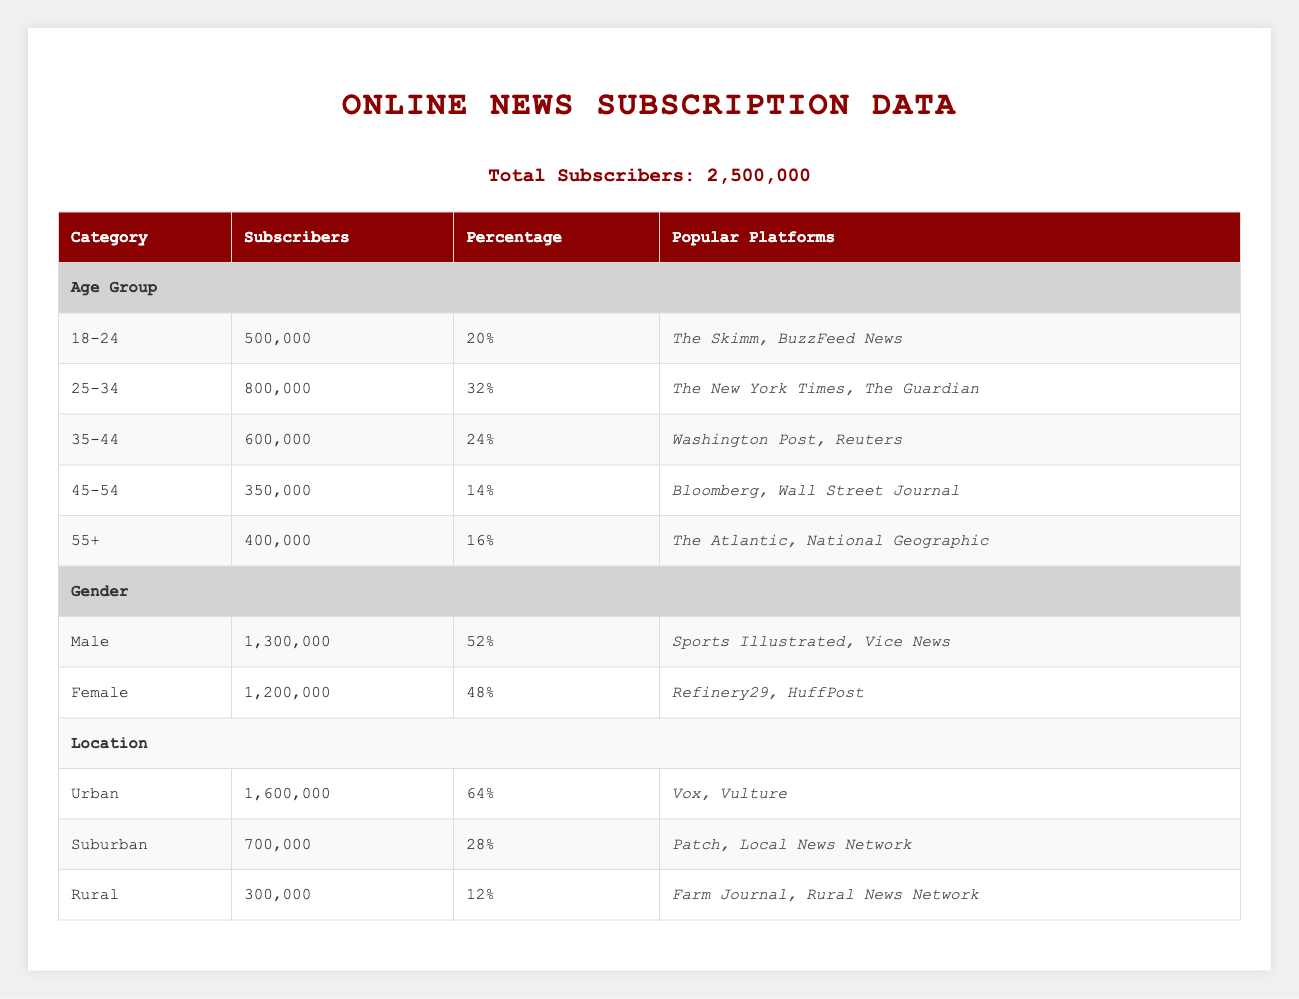What is the total number of subscribers for the online news platforms? The total number of subscribers is stated clearly at the top of the table as 2,500,000.
Answer: 2,500,000 Which age group has the highest number of subscribers? By reviewing the age group data, the group 25-34 has 800,000 subscribers, which is the highest compared to other age groups.
Answer: 25-34 What percentage of subscribers are from urban locations? The table lists the urban subscribers as 1,600,000 out of a total of 2,500,000. To find the percentage, we divide 1,600,000 by 2,500,000 and multiply by 100. This results in 64%.
Answer: 64% Is the number of male subscribers greater than the number of female subscribers? The table shows 1,300,000 male subscribers and 1,200,000 female subscribers. Since 1,300,000 is greater than 1,200,000, the statement is true.
Answer: Yes What is the combined number of subscribers for the 45-54 and 55+ age groups? Adding the subscribers from both age groups gives us 350,000 (for 45-54) + 400,000 (for 55+) = 750,000. This is the total for both age groups.
Answer: 750,000 Which demographic has the least subscribers in terms of location? Looking at the location demographic, rural has the smallest number of subscribers at 300,000 compared to urban (1,600,000) and suburban (700,000).
Answer: Rural What is the average number of subscribers across all age groups? To find the average, we sum the number of subscribers in each age group: 500,000 + 800,000 + 600,000 + 350,000 + 400,000 = 2,650,000. Dividing by the five age groups gives an average of 2,650,000 / 5 = 530,000.
Answer: 530,000 How many more subscribers are there among males than females? Males have 1,300,000 subscribers while females have 1,200,000. Calculating the difference, 1,300,000 - 1,200,000 equals 100,000 subscribers more for males.
Answer: 100,000 Which popular platform is associated with the female demographic? The popular platforms for female subscribers are listed as Refinery29 and HuffPost in the table.
Answer: Refinery29, HuffPost 